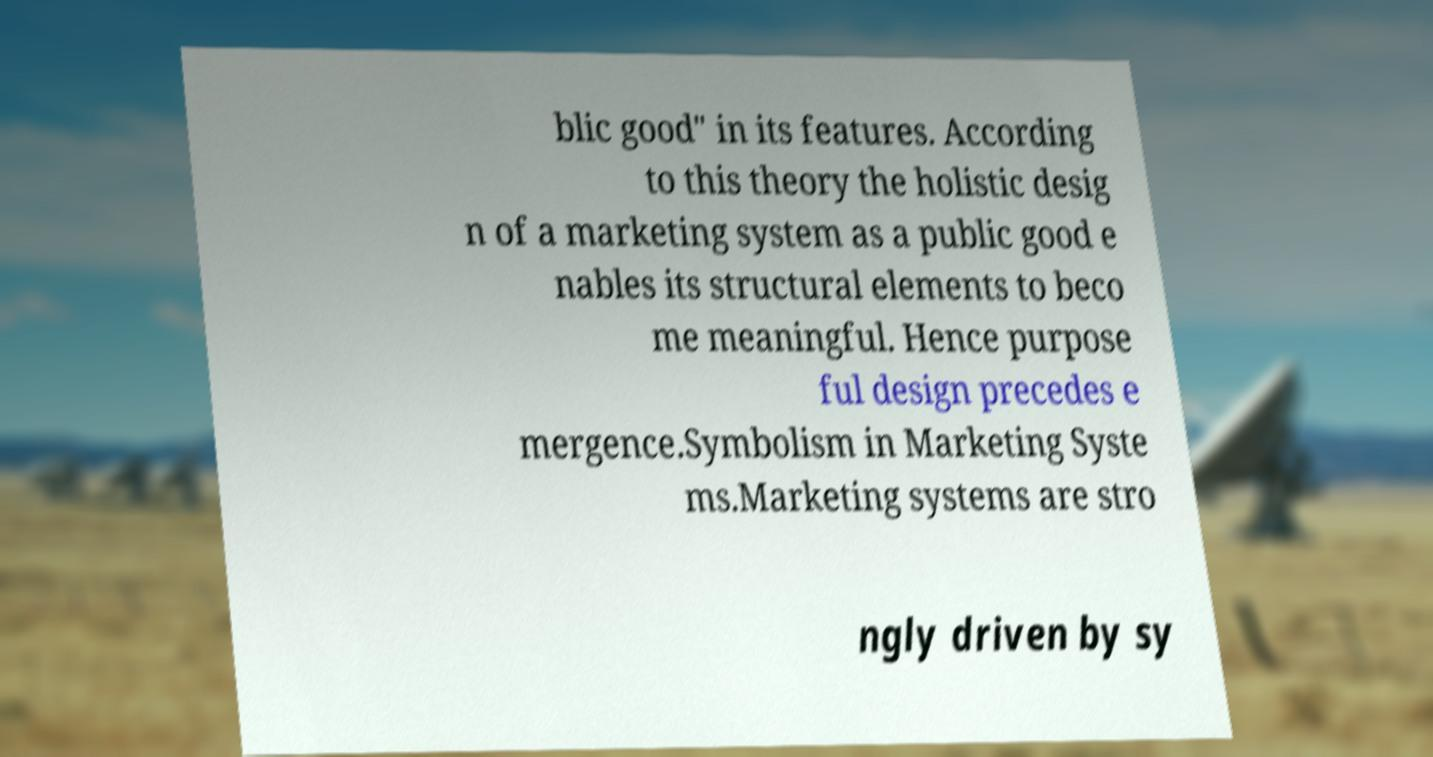What messages or text are displayed in this image? I need them in a readable, typed format. blic good" in its features. According to this theory the holistic desig n of a marketing system as a public good e nables its structural elements to beco me meaningful. Hence purpose ful design precedes e mergence.Symbolism in Marketing Syste ms.Marketing systems are stro ngly driven by sy 